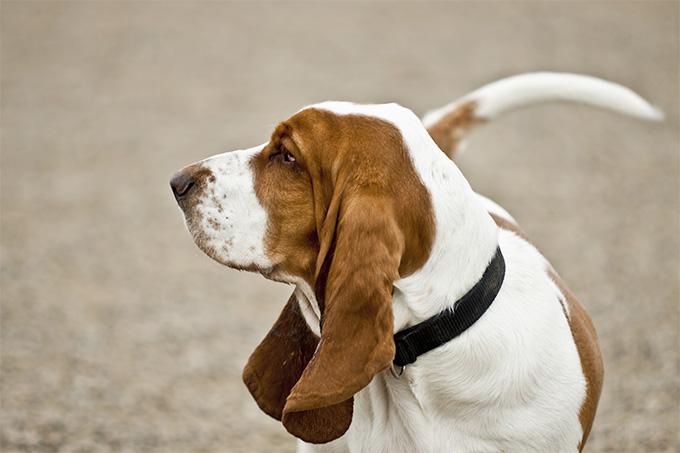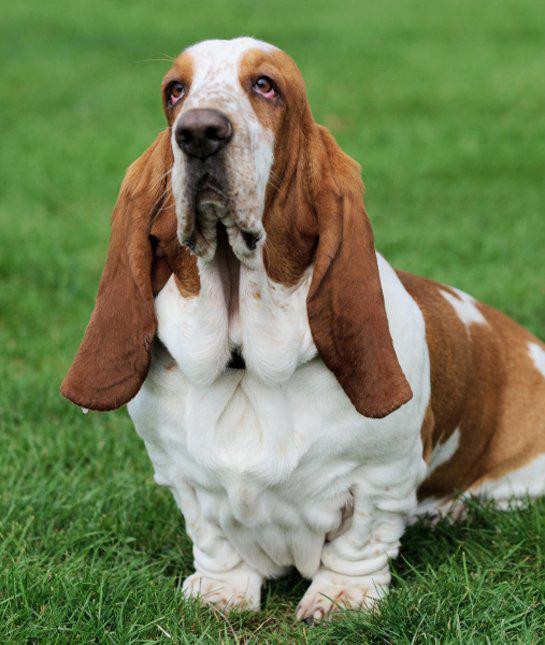The first image is the image on the left, the second image is the image on the right. For the images shown, is this caption "The dog in the image on the right is outside." true? Answer yes or no. Yes. 